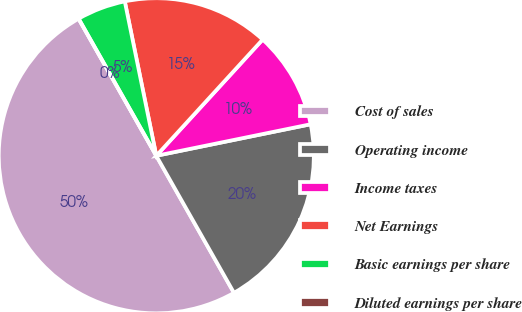Convert chart. <chart><loc_0><loc_0><loc_500><loc_500><pie_chart><fcel>Cost of sales<fcel>Operating income<fcel>Income taxes<fcel>Net Earnings<fcel>Basic earnings per share<fcel>Diluted earnings per share<nl><fcel>50.0%<fcel>20.0%<fcel>10.0%<fcel>15.0%<fcel>5.0%<fcel>0.0%<nl></chart> 